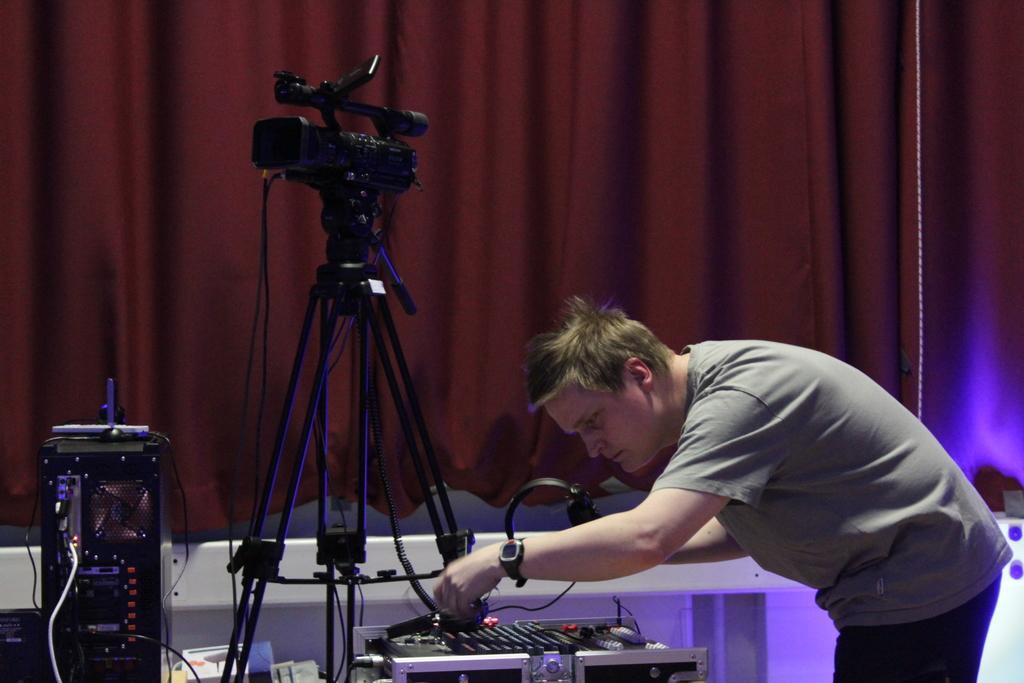Please provide a concise description of this image. In this image I can see a person wearing grey and black colored dress is standing and holding few objects. I can see few electronic equipment in front of him and a camera which is black in color. In the background I can see the brown colored curtain. 